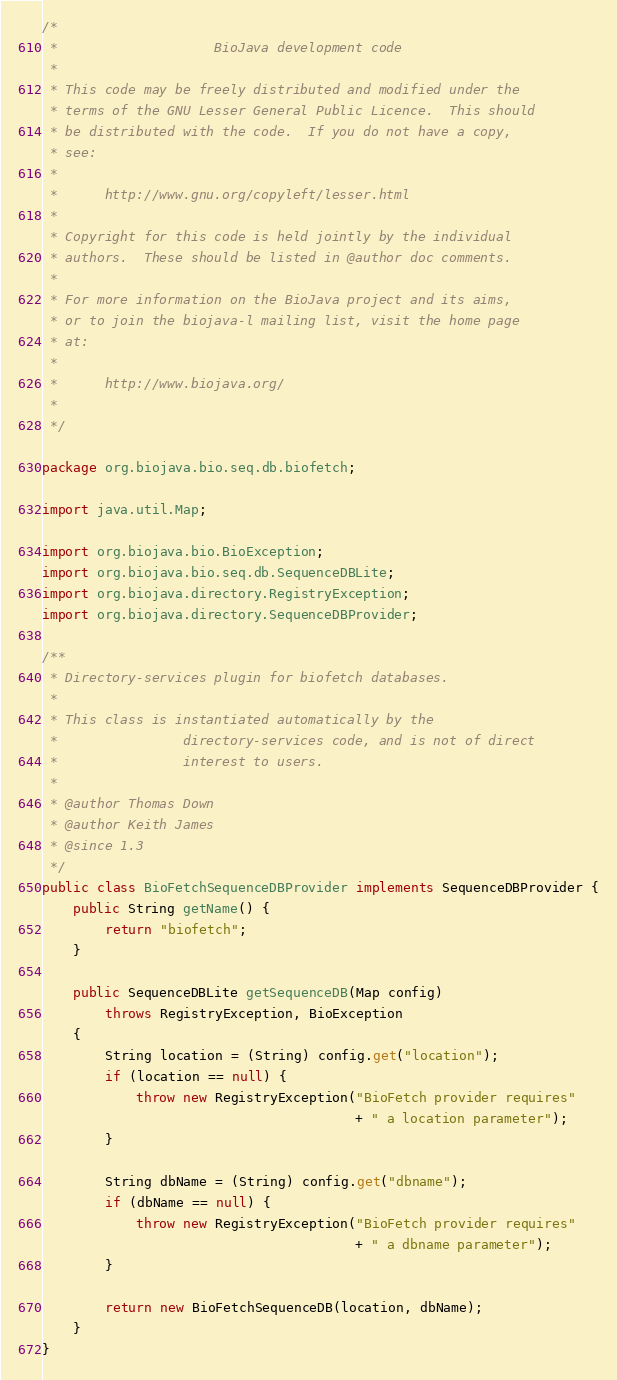Convert code to text. <code><loc_0><loc_0><loc_500><loc_500><_Java_>/*
 *                    BioJava development code
 *
 * This code may be freely distributed and modified under the
 * terms of the GNU Lesser General Public Licence.  This should
 * be distributed with the code.  If you do not have a copy,
 * see:
 *
 *      http://www.gnu.org/copyleft/lesser.html
 *
 * Copyright for this code is held jointly by the individual
 * authors.  These should be listed in @author doc comments.
 *
 * For more information on the BioJava project and its aims,
 * or to join the biojava-l mailing list, visit the home page
 * at:
 *
 *      http://www.biojava.org/
 *
 */

package org.biojava.bio.seq.db.biofetch;

import java.util.Map;

import org.biojava.bio.BioException;
import org.biojava.bio.seq.db.SequenceDBLite;
import org.biojava.directory.RegistryException;
import org.biojava.directory.SequenceDBProvider;

/**
 * Directory-services plugin for biofetch databases.
 *
 * This class is instantiated automatically by the
 *                directory-services code, and is not of direct
 *                interest to users.
 *
 * @author Thomas Down
 * @author Keith James
 * @since 1.3
 */
public class BioFetchSequenceDBProvider implements SequenceDBProvider {
    public String getName() {
        return "biofetch";
    }

    public SequenceDBLite getSequenceDB(Map config)
        throws RegistryException, BioException
    {
        String location = (String) config.get("location");
        if (location == null) {
            throw new RegistryException("BioFetch provider requires"
                                        + " a location parameter");
        }

        String dbName = (String) config.get("dbname");
        if (dbName == null) {
            throw new RegistryException("BioFetch provider requires"
                                        + " a dbname parameter");
        }

        return new BioFetchSequenceDB(location, dbName);
    }
}
</code> 